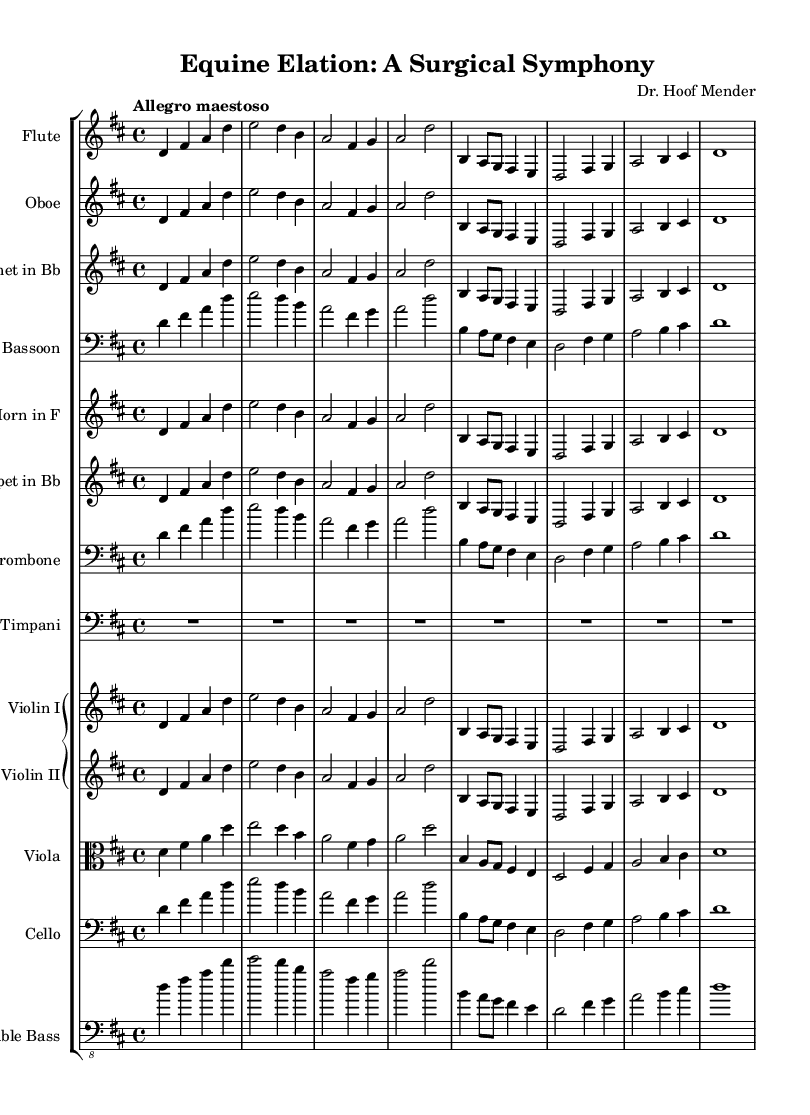What is the title of this composition? The title is located at the top of the sheet music, labeled clearly.
Answer: Equine Elation: A Surgical Symphony What is the key signature of this music? The key signature is indicated by the number of sharps or flats at the beginning of the staff. In this score, there are two sharps.
Answer: D major What is the time signature of this music? The time signature appears right after the key signature on the staff. In this piece, it is 4/4, indicating four beats per measure.
Answer: 4/4 What is the tempo marking of this music? The tempo marking is found at the beginning and indicates the speed of the piece. Here, it states "Allegro maestoso," suggesting a fast and majestic pace.
Answer: Allegro maestoso Which instruments are featured in this orchestral suite? The names of the instruments are listed at the beginning of each staff. This includes flute, oboe, clarinet, bassoon, horn, trumpet, trombone, timpani, violin I, violin II, viola, cello, and double bass.
Answer: Flute, Oboe, Clarinet, Bassoon, Horn, Trumpet, Trombone, Timpani, Violin I, Violin II, Viola, Cello, Double Bass How many main themes are presented in the piece? The score provides a thematic structure, where the main theme is presented in two sections, which is a common structure in orchestral suites. Thus, one main theme and one secondary theme exist.
Answer: 2 Which instrument plays the primary melody? The primary melody is typically introduced and carried by the flute in orchestral compositions, as indicated by its placement.
Answer: Flute 